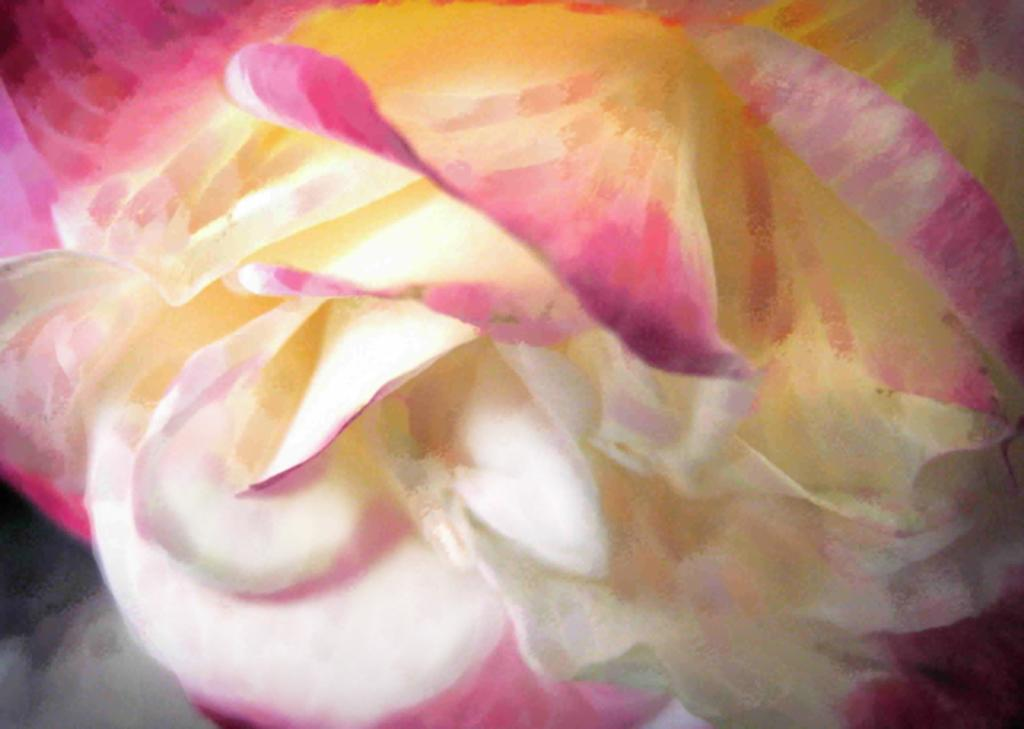What type of artwork is depicted in the image? The image is a painting. What is the main subject of the painting? There is a flower in the painting. What type of sail can be seen in the painting? There is no sail present in the painting, as it features a flower. How does the twig contribute to the painting's composition? There is no mention of a twig in the painting; it only features a flower. 